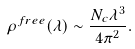Convert formula to latex. <formula><loc_0><loc_0><loc_500><loc_500>\rho ^ { f r e e } ( \lambda ) \sim \frac { N _ { c } \lambda ^ { 3 } } { 4 \pi ^ { 2 } } .</formula> 